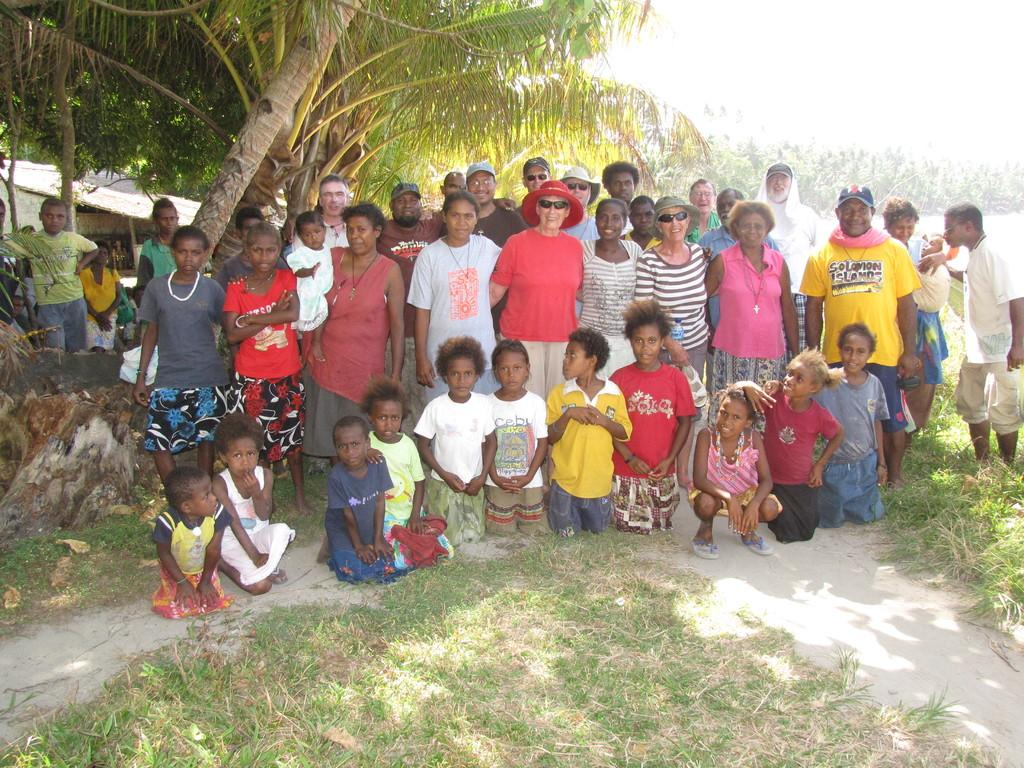How many people are in the group visible in the image? There is a group of people in the image, but the exact number cannot be determined from the provided facts. What is the position of the people in the image? The people are on the ground in the image. What type of natural environment is visible in the image? There is grass visible in the image, which suggests a grassy or park-like setting. What type of structure can be seen in the image? There is a hut in the image. What type of vegetation is visible in the image? There are trees in the image. What type of system is being used by the goldfish in the image? There is no goldfish present in the image, so it is not possible to determine what type of system might be used by them. 